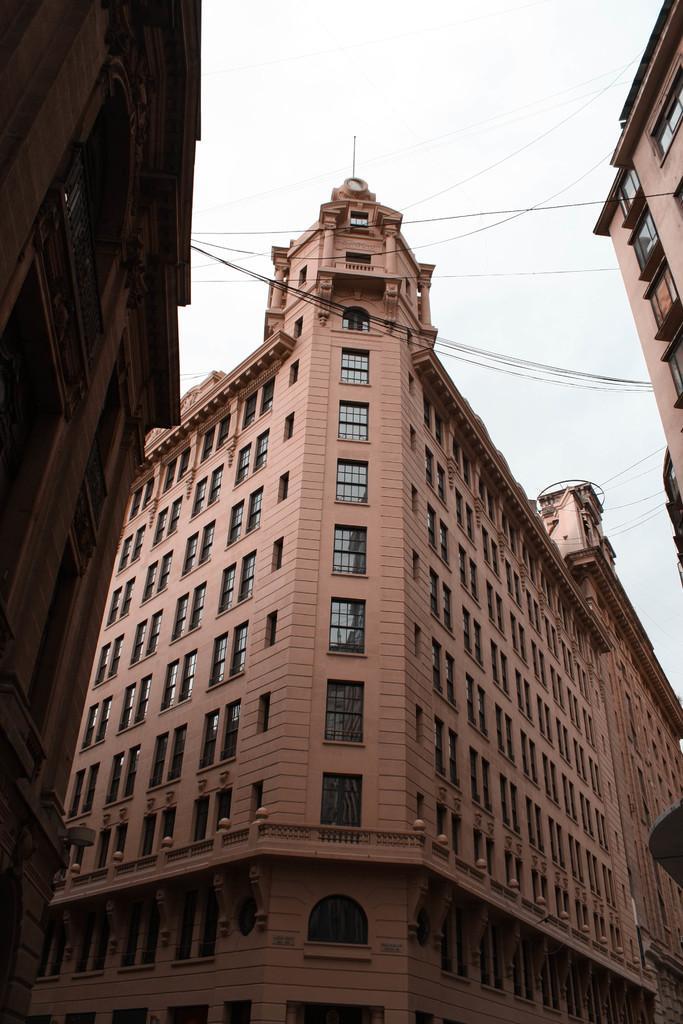Please provide a concise description of this image. In this picture we can see buildings and wires and we can see sky in the background. 